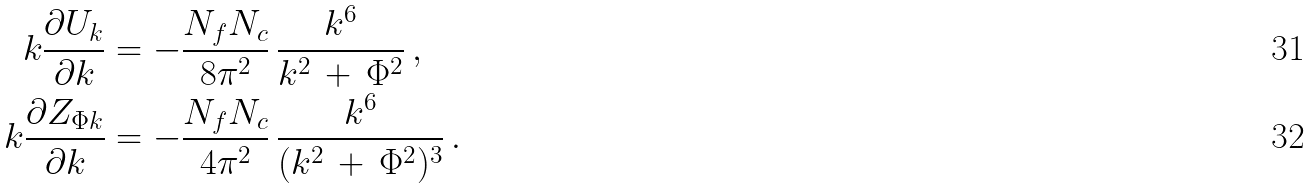Convert formula to latex. <formula><loc_0><loc_0><loc_500><loc_500>k \frac { \partial U _ { k } } { \partial k } & = - \frac { N _ { f } N _ { c } } { 8 \pi ^ { 2 } } \, \frac { k ^ { 6 } } { k ^ { 2 } \, + \, \Phi ^ { 2 } } \, , \\ k \frac { \partial Z _ { \Phi k } } { \partial k } & = - \frac { N _ { f } N _ { c } } { 4 \pi ^ { 2 } } \, \frac { k ^ { 6 } } { ( k ^ { 2 } \, + \, \Phi ^ { 2 } ) ^ { 3 } } \, .</formula> 